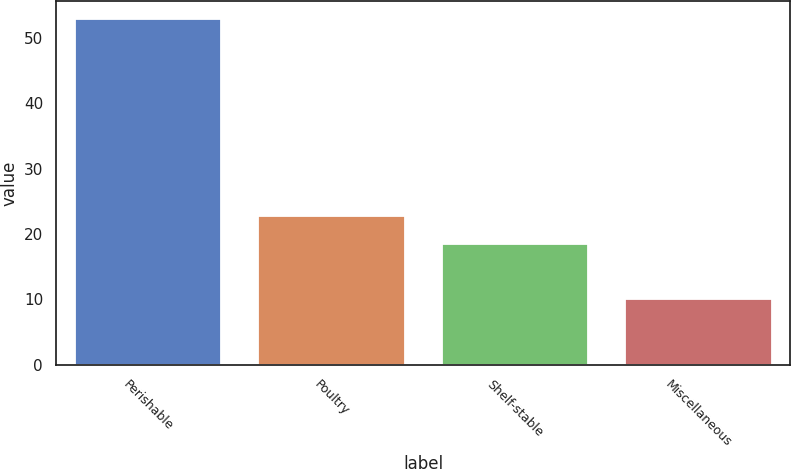Convert chart. <chart><loc_0><loc_0><loc_500><loc_500><bar_chart><fcel>Perishable<fcel>Poultry<fcel>Shelf-stable<fcel>Miscellaneous<nl><fcel>53<fcel>22.7<fcel>18.4<fcel>10<nl></chart> 